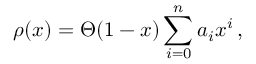Convert formula to latex. <formula><loc_0><loc_0><loc_500><loc_500>\rho ( x ) = \Theta ( 1 - x ) \sum _ { i = 0 } ^ { n } a _ { i } x ^ { i } \, ,</formula> 